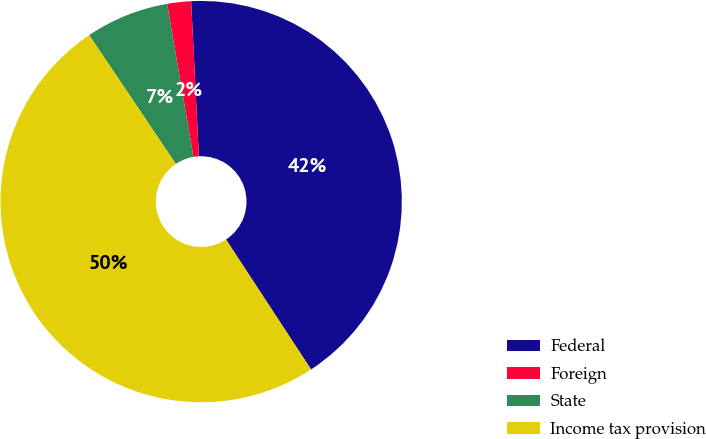<chart> <loc_0><loc_0><loc_500><loc_500><pie_chart><fcel>Federal<fcel>Foreign<fcel>State<fcel>Income tax provision<nl><fcel>41.57%<fcel>1.92%<fcel>6.71%<fcel>49.8%<nl></chart> 